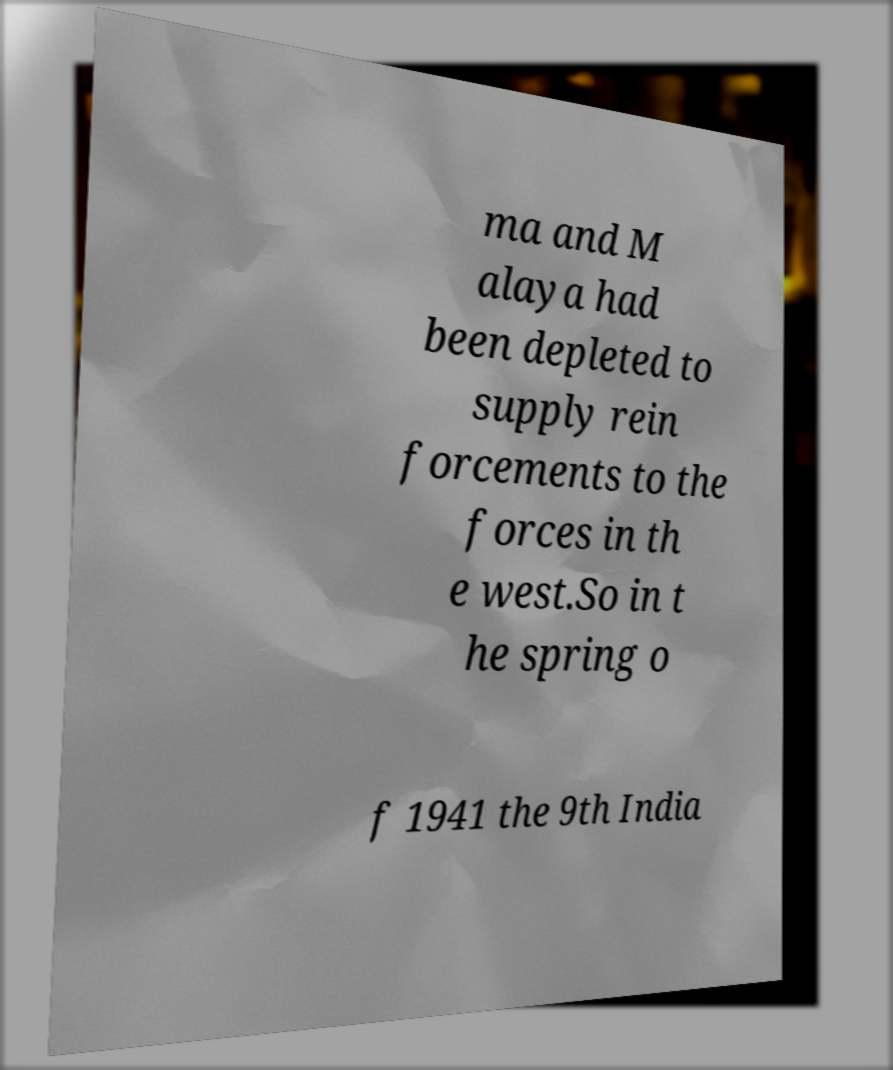Could you assist in decoding the text presented in this image and type it out clearly? ma and M alaya had been depleted to supply rein forcements to the forces in th e west.So in t he spring o f 1941 the 9th India 